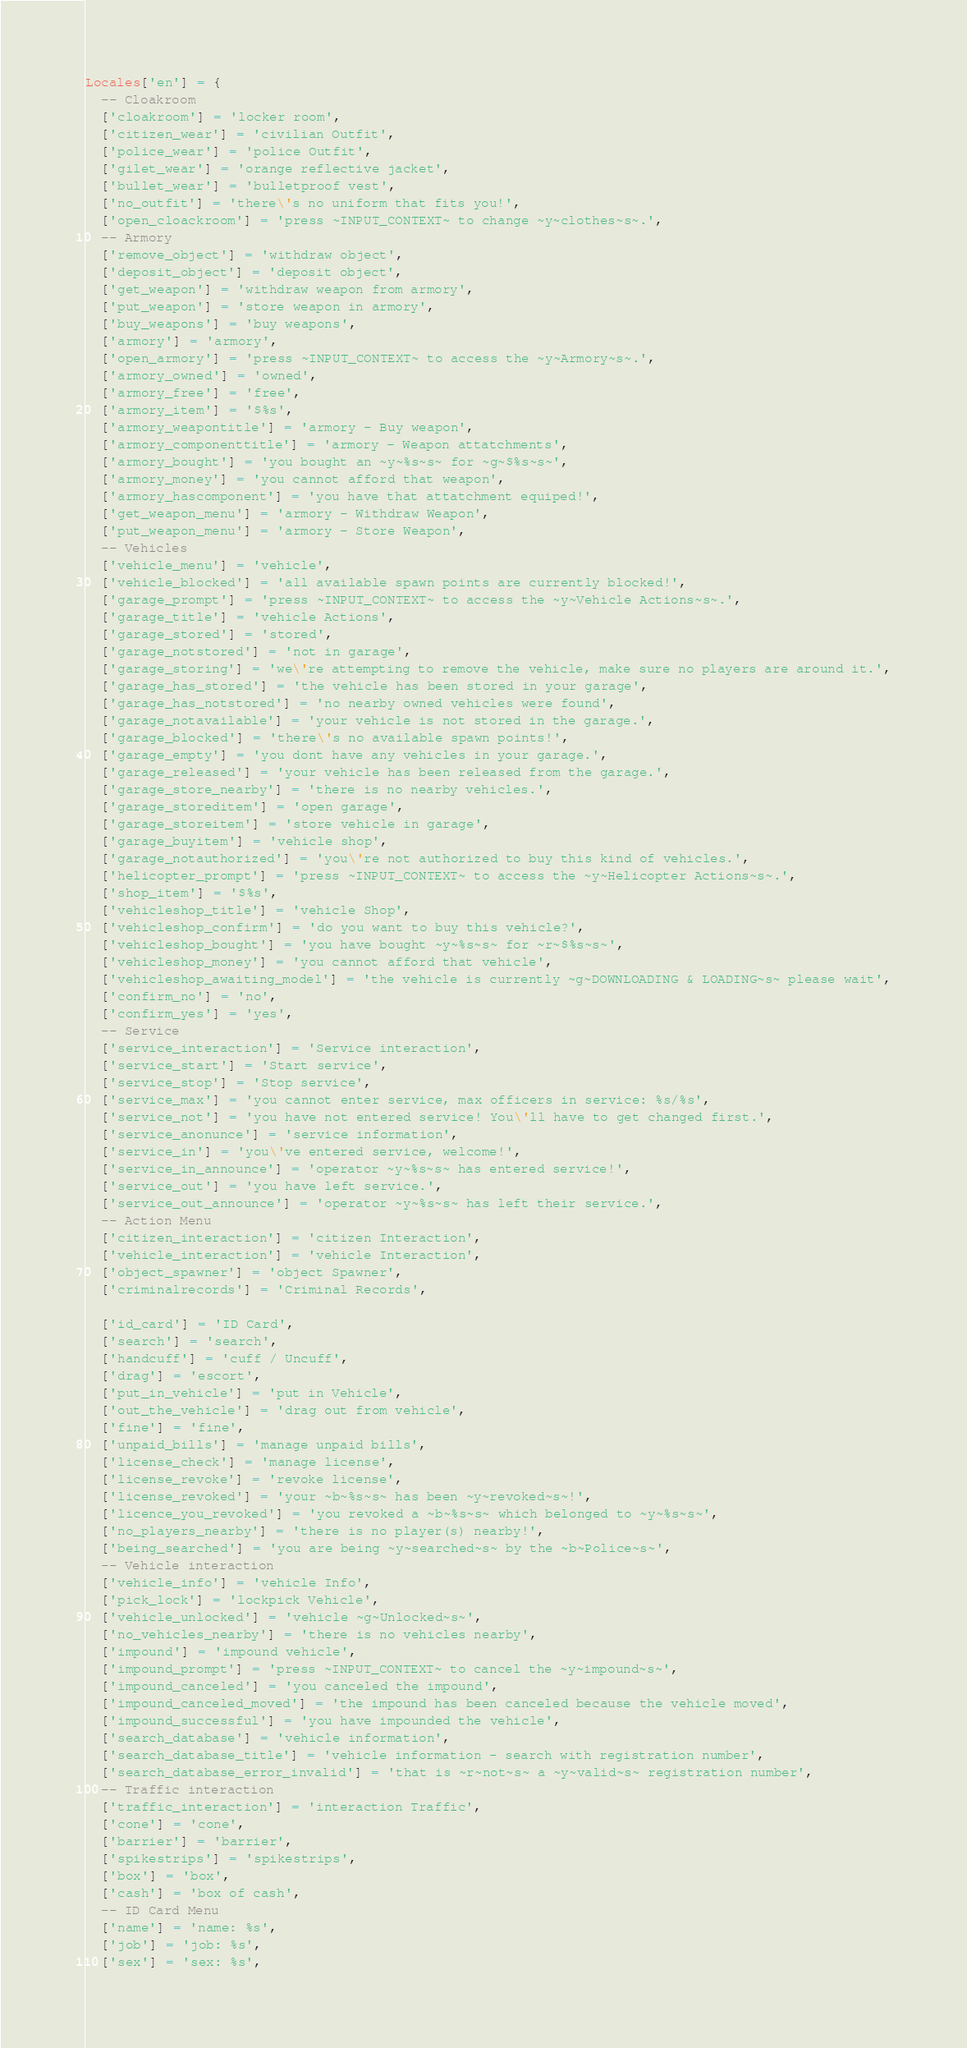<code> <loc_0><loc_0><loc_500><loc_500><_Lua_>Locales['en'] = {
  -- Cloakroom
  ['cloakroom'] = 'locker room',
  ['citizen_wear'] = 'civilian Outfit',
  ['police_wear'] = 'police Outfit',
  ['gilet_wear'] = 'orange reflective jacket',
  ['bullet_wear'] = 'bulletproof vest',
  ['no_outfit'] = 'there\'s no uniform that fits you!',
  ['open_cloackroom'] = 'press ~INPUT_CONTEXT~ to change ~y~clothes~s~.',
  -- Armory
  ['remove_object'] = 'withdraw object',
  ['deposit_object'] = 'deposit object',
  ['get_weapon'] = 'withdraw weapon from armory',
  ['put_weapon'] = 'store weapon in armory',
  ['buy_weapons'] = 'buy weapons',
  ['armory'] = 'armory',
  ['open_armory'] = 'press ~INPUT_CONTEXT~ to access the ~y~Armory~s~.',
  ['armory_owned'] = 'owned',
  ['armory_free'] = 'free',
  ['armory_item'] = '$%s',
  ['armory_weapontitle'] = 'armory - Buy weapon',
  ['armory_componenttitle'] = 'armory - Weapon attatchments',
  ['armory_bought'] = 'you bought an ~y~%s~s~ for ~g~$%s~s~',
  ['armory_money'] = 'you cannot afford that weapon',
  ['armory_hascomponent'] = 'you have that attatchment equiped!',
  ['get_weapon_menu'] = 'armory - Withdraw Weapon',
  ['put_weapon_menu'] = 'armory - Store Weapon',
  -- Vehicles
  ['vehicle_menu'] = 'vehicle',
  ['vehicle_blocked'] = 'all available spawn points are currently blocked!',
  ['garage_prompt'] = 'press ~INPUT_CONTEXT~ to access the ~y~Vehicle Actions~s~.',
  ['garage_title'] = 'vehicle Actions',
  ['garage_stored'] = 'stored',
  ['garage_notstored'] = 'not in garage',
  ['garage_storing'] = 'we\'re attempting to remove the vehicle, make sure no players are around it.',
  ['garage_has_stored'] = 'the vehicle has been stored in your garage',
  ['garage_has_notstored'] = 'no nearby owned vehicles were found',
  ['garage_notavailable'] = 'your vehicle is not stored in the garage.',
  ['garage_blocked'] = 'there\'s no available spawn points!',
  ['garage_empty'] = 'you dont have any vehicles in your garage.',
  ['garage_released'] = 'your vehicle has been released from the garage.',
  ['garage_store_nearby'] = 'there is no nearby vehicles.',
  ['garage_storeditem'] = 'open garage',
  ['garage_storeitem'] = 'store vehicle in garage',
  ['garage_buyitem'] = 'vehicle shop',
  ['garage_notauthorized'] = 'you\'re not authorized to buy this kind of vehicles.',
  ['helicopter_prompt'] = 'press ~INPUT_CONTEXT~ to access the ~y~Helicopter Actions~s~.',
  ['shop_item'] = '$%s',
  ['vehicleshop_title'] = 'vehicle Shop',
  ['vehicleshop_confirm'] = 'do you want to buy this vehicle?',
  ['vehicleshop_bought'] = 'you have bought ~y~%s~s~ for ~r~$%s~s~',
  ['vehicleshop_money'] = 'you cannot afford that vehicle',
  ['vehicleshop_awaiting_model'] = 'the vehicle is currently ~g~DOWNLOADING & LOADING~s~ please wait',
  ['confirm_no'] = 'no',
  ['confirm_yes'] = 'yes',
  -- Service
  ['service_interaction'] = 'Service interaction',  
  ['service_start'] = 'Start service',  
  ['service_stop'] = 'Stop service',  
  ['service_max'] = 'you cannot enter service, max officers in service: %s/%s',
  ['service_not'] = 'you have not entered service! You\'ll have to get changed first.',
  ['service_anonunce'] = 'service information',
  ['service_in'] = 'you\'ve entered service, welcome!',
  ['service_in_announce'] = 'operator ~y~%s~s~ has entered service!',
  ['service_out'] = 'you have left service.',
  ['service_out_announce'] = 'operator ~y~%s~s~ has left their service.',
  -- Action Menu
  ['citizen_interaction'] = 'citizen Interaction',
  ['vehicle_interaction'] = 'vehicle Interaction',
  ['object_spawner'] = 'object Spawner',
  ['criminalrecords'] = 'Criminal Records',

  ['id_card'] = 'ID Card',
  ['search'] = 'search',
  ['handcuff'] = 'cuff / Uncuff',
  ['drag'] = 'escort',
  ['put_in_vehicle'] = 'put in Vehicle',
  ['out_the_vehicle'] = 'drag out from vehicle',
  ['fine'] = 'fine',
  ['unpaid_bills'] = 'manage unpaid bills',
  ['license_check'] = 'manage license',
  ['license_revoke'] = 'revoke license',
  ['license_revoked'] = 'your ~b~%s~s~ has been ~y~revoked~s~!',
  ['licence_you_revoked'] = 'you revoked a ~b~%s~s~ which belonged to ~y~%s~s~',
  ['no_players_nearby'] = 'there is no player(s) nearby!',
  ['being_searched'] = 'you are being ~y~searched~s~ by the ~b~Police~s~',
  -- Vehicle interaction
  ['vehicle_info'] = 'vehicle Info',
  ['pick_lock'] = 'lockpick Vehicle',
  ['vehicle_unlocked'] = 'vehicle ~g~Unlocked~s~',
  ['no_vehicles_nearby'] = 'there is no vehicles nearby',
  ['impound'] = 'impound vehicle',
  ['impound_prompt'] = 'press ~INPUT_CONTEXT~ to cancel the ~y~impound~s~',
  ['impound_canceled'] = 'you canceled the impound',
  ['impound_canceled_moved'] = 'the impound has been canceled because the vehicle moved',
  ['impound_successful'] = 'you have impounded the vehicle',
  ['search_database'] = 'vehicle information',
  ['search_database_title'] = 'vehicle information - search with registration number',
  ['search_database_error_invalid'] = 'that is ~r~not~s~ a ~y~valid~s~ registration number',
  -- Traffic interaction
  ['traffic_interaction'] = 'interaction Traffic',
  ['cone'] = 'cone',
  ['barrier'] = 'barrier',
  ['spikestrips'] = 'spikestrips',
  ['box'] = 'box',
  ['cash'] = 'box of cash',
  -- ID Card Menu
  ['name'] = 'name: %s',
  ['job'] = 'job: %s',
  ['sex'] = 'sex: %s',</code> 